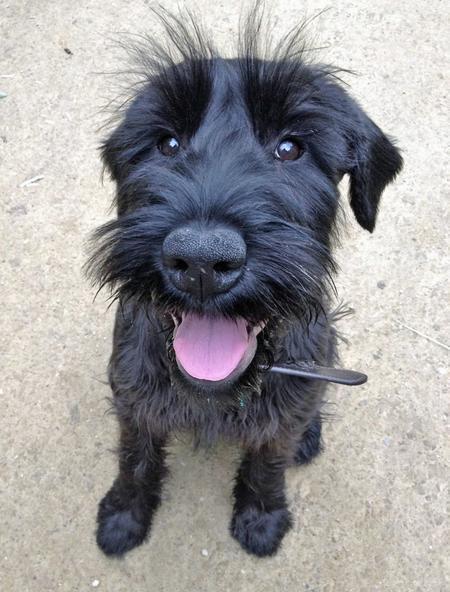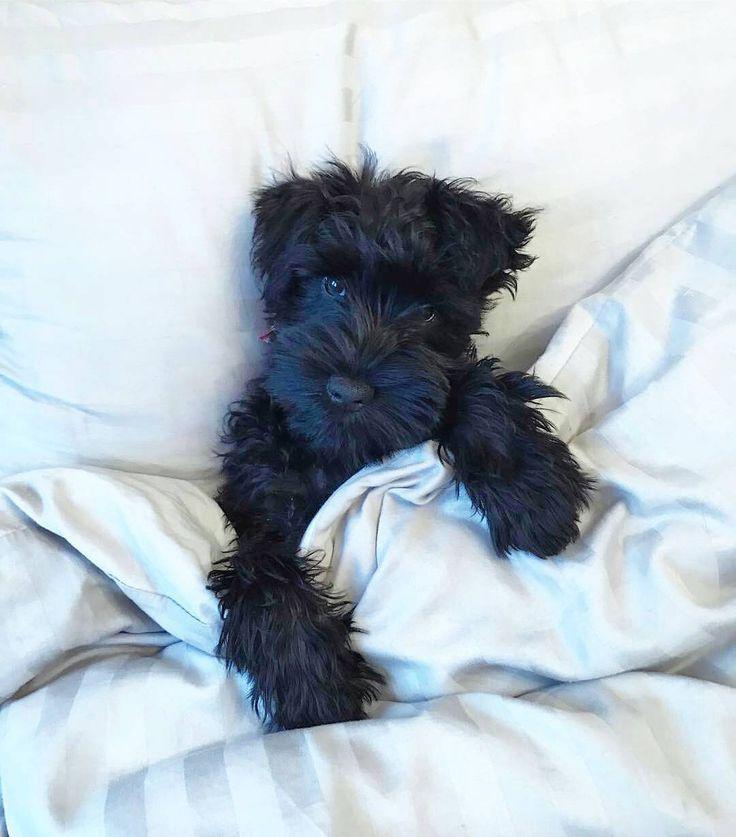The first image is the image on the left, the second image is the image on the right. Given the left and right images, does the statement "Each image contains exactly one schnauzer, and one image shows a schnauzer in some type of bed." hold true? Answer yes or no. Yes. The first image is the image on the left, the second image is the image on the right. For the images displayed, is the sentence "there is a dog laying in bed" factually correct? Answer yes or no. Yes. 